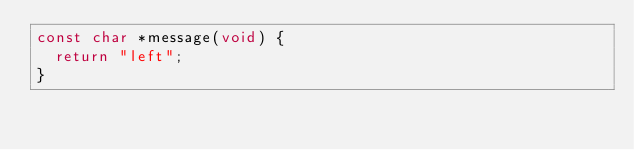Convert code to text. <code><loc_0><loc_0><loc_500><loc_500><_C_>const char *message(void) {
  return "left";
}
</code> 